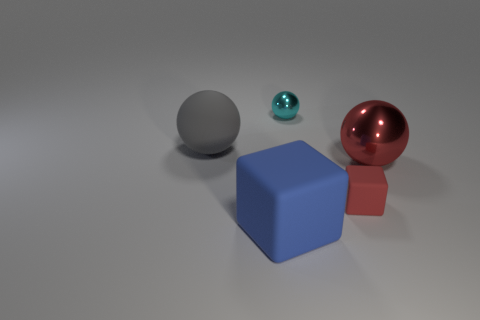Add 2 blue objects. How many objects exist? 7 Subtract all spheres. How many objects are left? 2 Subtract 1 blue blocks. How many objects are left? 4 Subtract all blue objects. Subtract all tiny blocks. How many objects are left? 3 Add 3 small cyan metal objects. How many small cyan metal objects are left? 4 Add 2 large green matte spheres. How many large green matte spheres exist? 2 